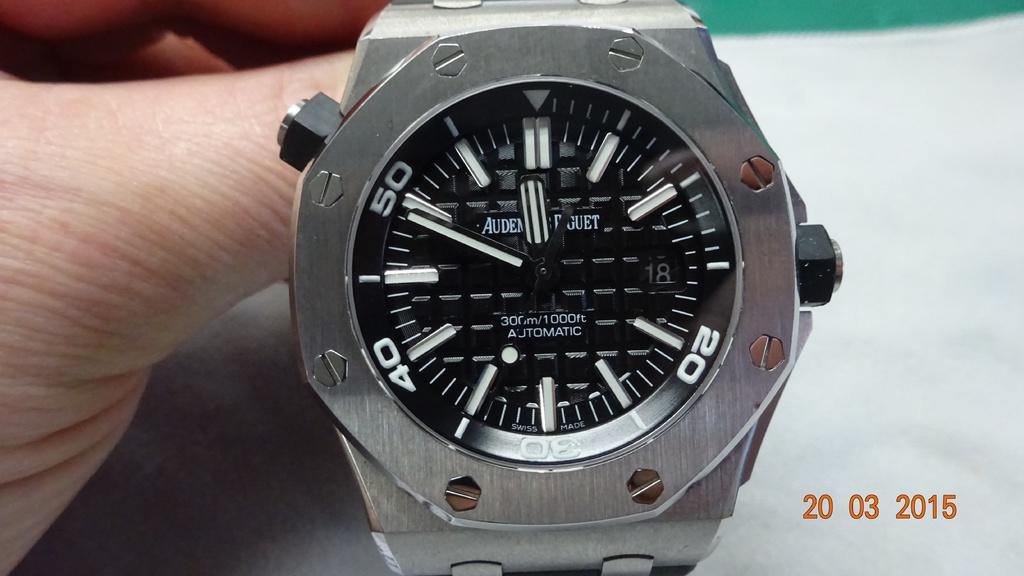<image>
Relay a brief, clear account of the picture shown. a wrist watch with words AUDEN is displayed on a white table 